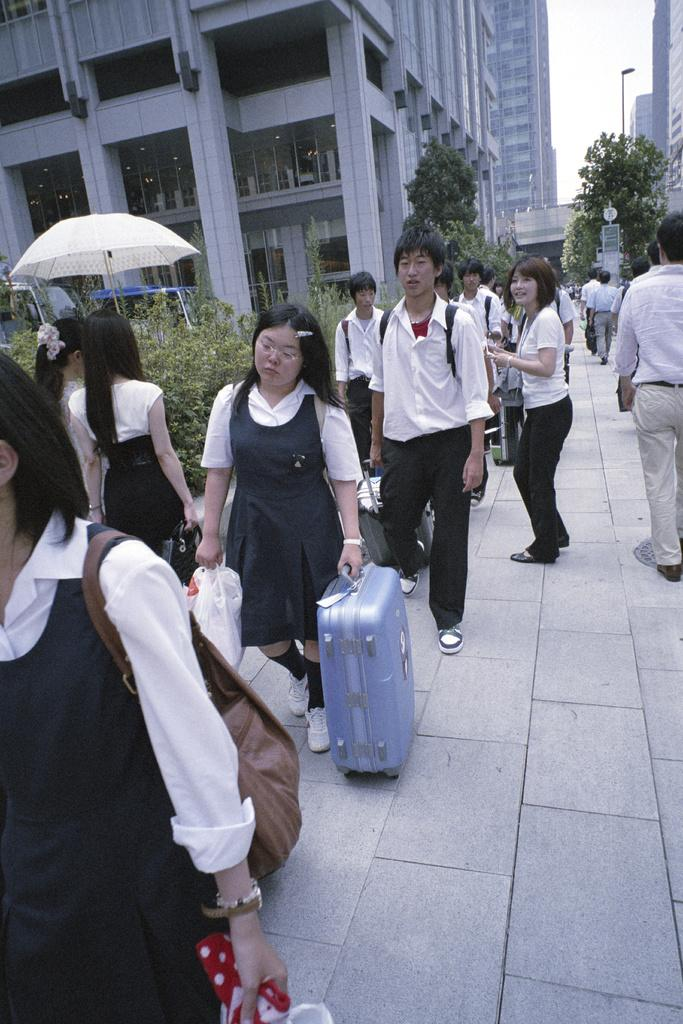What type of structure is present in the image? There is a building in the image. What can be seen in the background of the image? The sky is visible in the image. What type of vegetation is present in the image? There are plants in the image. What object is used for protection from the rain in the image? There is an umbrella in the image. How many people are visible in the image? There are people in the image. What is the woman holding in the image? There is a woman holding a suitcase in the image. What type of cream is being used in the battle depicted in the image? There is no battle or cream present in the image. What type of straw is being used by the people in the image? There is no straw present in the image. 